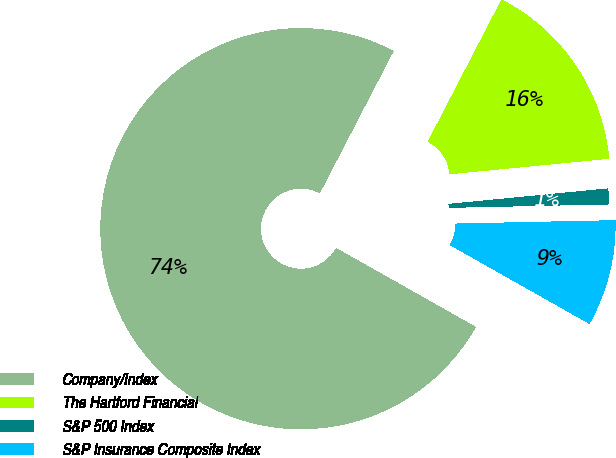Convert chart. <chart><loc_0><loc_0><loc_500><loc_500><pie_chart><fcel>Company/Index<fcel>The Hartford Financial<fcel>S&P 500 Index<fcel>S&P Insurance Composite Index<nl><fcel>74.44%<fcel>15.85%<fcel>1.2%<fcel>8.52%<nl></chart> 